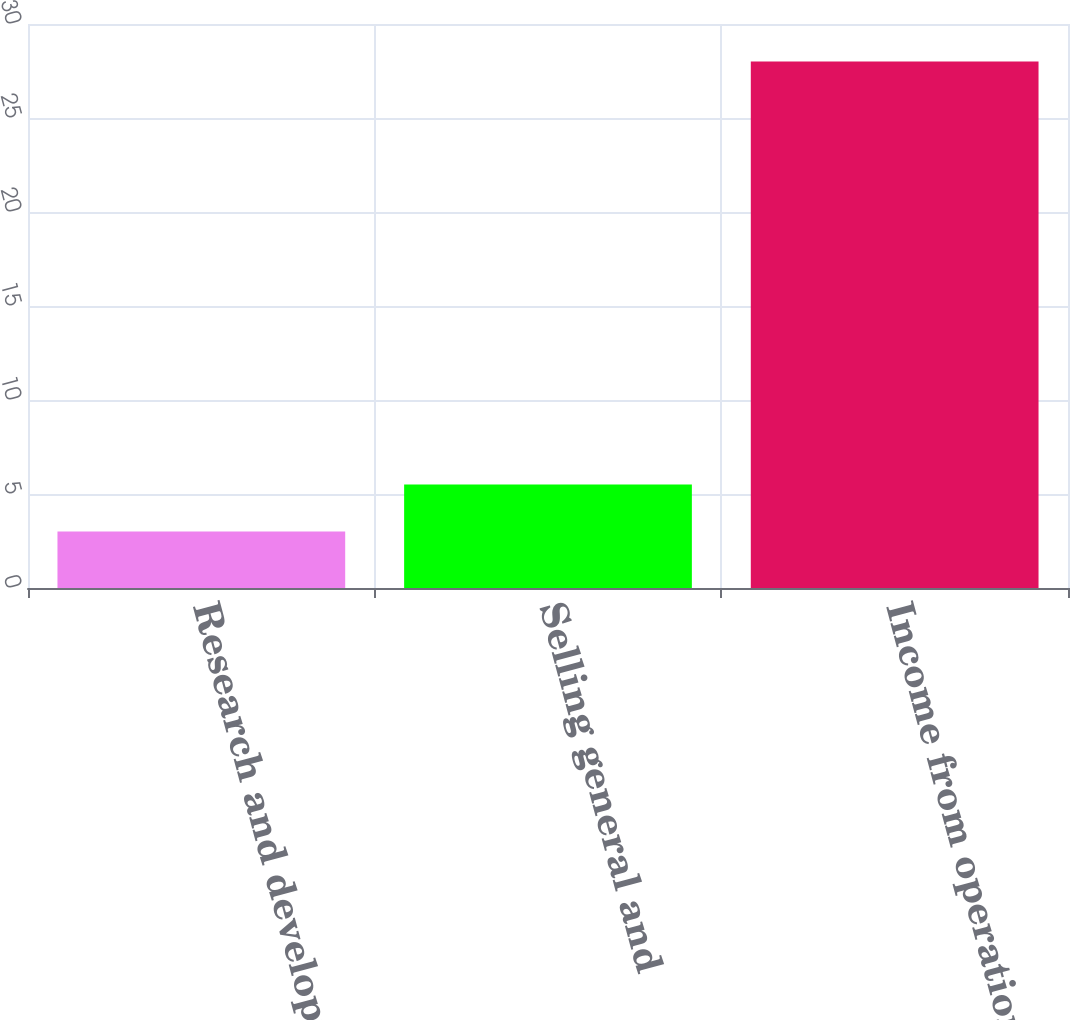Convert chart to OTSL. <chart><loc_0><loc_0><loc_500><loc_500><bar_chart><fcel>Research and development<fcel>Selling general and<fcel>Income from operations<nl><fcel>3<fcel>5.5<fcel>28<nl></chart> 